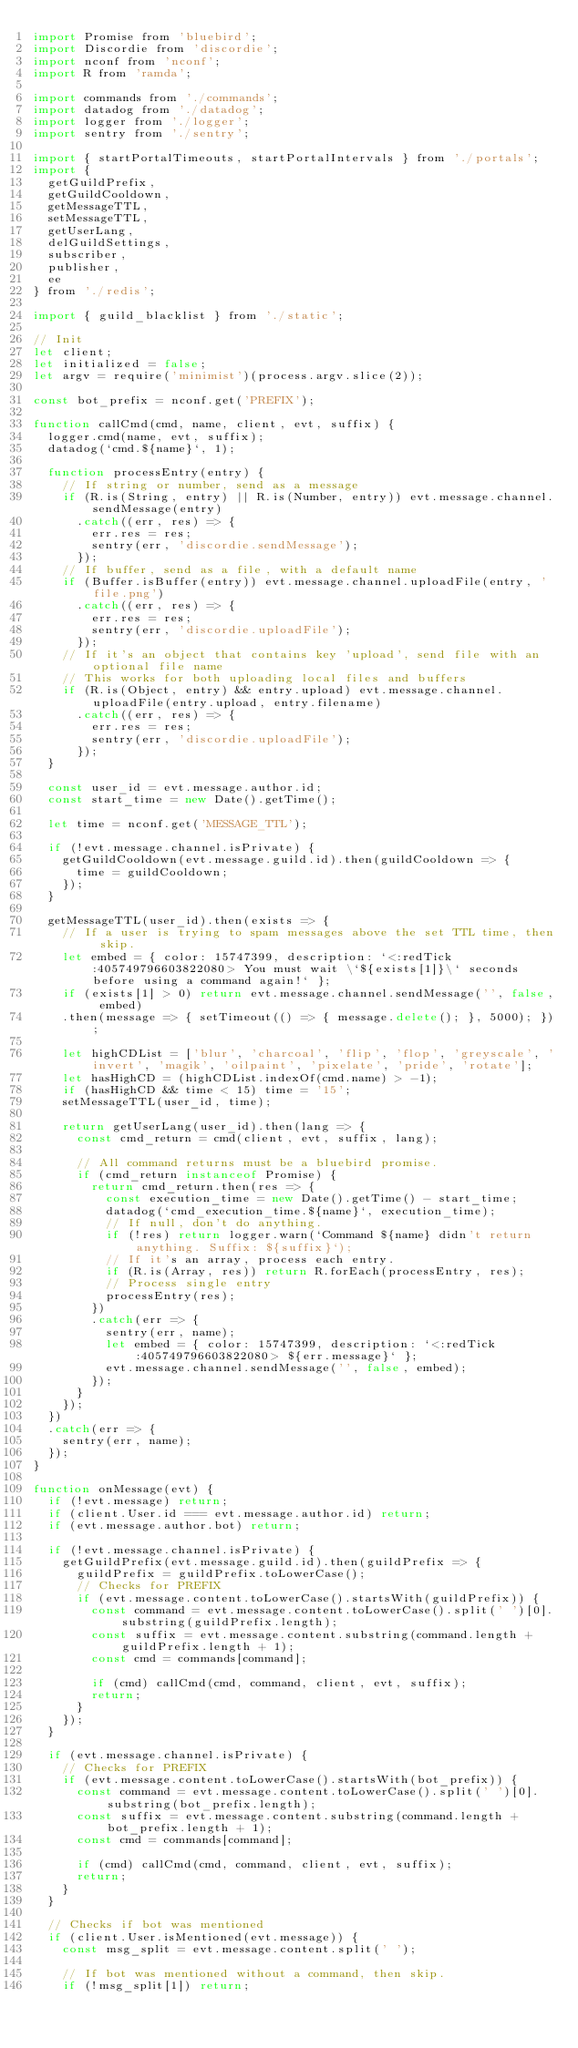Convert code to text. <code><loc_0><loc_0><loc_500><loc_500><_JavaScript_>import Promise from 'bluebird';
import Discordie from 'discordie';
import nconf from 'nconf';
import R from 'ramda';

import commands from './commands';
import datadog from './datadog';
import logger from './logger';
import sentry from './sentry';

import { startPortalTimeouts, startPortalIntervals } from './portals';
import {
  getGuildPrefix,
  getGuildCooldown,
  getMessageTTL,
  setMessageTTL,
  getUserLang,
  delGuildSettings,
  subscriber,
  publisher,
  ee
} from './redis';

import { guild_blacklist } from './static';

// Init
let client;
let initialized = false;
let argv = require('minimist')(process.argv.slice(2));

const bot_prefix = nconf.get('PREFIX');

function callCmd(cmd, name, client, evt, suffix) {
  logger.cmd(name, evt, suffix);
  datadog(`cmd.${name}`, 1);

  function processEntry(entry) {
    // If string or number, send as a message
    if (R.is(String, entry) || R.is(Number, entry)) evt.message.channel.sendMessage(entry)
      .catch((err, res) => {
        err.res = res;
        sentry(err, 'discordie.sendMessage');
      });
    // If buffer, send as a file, with a default name
    if (Buffer.isBuffer(entry)) evt.message.channel.uploadFile(entry, 'file.png')
      .catch((err, res) => {
        err.res = res;
        sentry(err, 'discordie.uploadFile');
      });
    // If it's an object that contains key 'upload', send file with an optional file name
    // This works for both uploading local files and buffers
    if (R.is(Object, entry) && entry.upload) evt.message.channel.uploadFile(entry.upload, entry.filename)
      .catch((err, res) => {
        err.res = res;
        sentry(err, 'discordie.uploadFile');
      });
  }

  const user_id = evt.message.author.id;
  const start_time = new Date().getTime();

  let time = nconf.get('MESSAGE_TTL');

  if (!evt.message.channel.isPrivate) {
    getGuildCooldown(evt.message.guild.id).then(guildCooldown => {
      time = guildCooldown;
    });
  }

  getMessageTTL(user_id).then(exists => {
    // If a user is trying to spam messages above the set TTL time, then skip.
    let embed = { color: 15747399, description: `<:redTick:405749796603822080> You must wait \`${exists[1]}\` seconds before using a command again!` };
    if (exists[1] > 0) return evt.message.channel.sendMessage('', false, embed)
    .then(message => { setTimeout(() => { message.delete(); }, 5000); });

    let highCDList = ['blur', 'charcoal', 'flip', 'flop', 'greyscale', 'invert', 'magik', 'oilpaint', 'pixelate', 'pride', 'rotate'];
    let hasHighCD = (highCDList.indexOf(cmd.name) > -1);
    if (hasHighCD && time < 15) time = '15';
    setMessageTTL(user_id, time);

    return getUserLang(user_id).then(lang => {
      const cmd_return = cmd(client, evt, suffix, lang);

      // All command returns must be a bluebird promise.
      if (cmd_return instanceof Promise) {
        return cmd_return.then(res => {
          const execution_time = new Date().getTime() - start_time;
          datadog(`cmd_execution_time.${name}`, execution_time);
          // If null, don't do anything.
          if (!res) return logger.warn(`Command ${name} didn't return anything. Suffix: ${suffix}`);
          // If it's an array, process each entry.
          if (R.is(Array, res)) return R.forEach(processEntry, res);
          // Process single entry
          processEntry(res);
        })
        .catch(err => {
          sentry(err, name);
          let embed = { color: 15747399, description: `<:redTick:405749796603822080> ${err.message}` };
          evt.message.channel.sendMessage('', false, embed);
        });
      }
    });
  })
  .catch(err => {
    sentry(err, name);
  });
}

function onMessage(evt) {
  if (!evt.message) return;
  if (client.User.id === evt.message.author.id) return;
  if (evt.message.author.bot) return;

  if (!evt.message.channel.isPrivate) {
    getGuildPrefix(evt.message.guild.id).then(guildPrefix => {
      guildPrefix = guildPrefix.toLowerCase();
      // Checks for PREFIX
      if (evt.message.content.toLowerCase().startsWith(guildPrefix)) {
        const command = evt.message.content.toLowerCase().split(' ')[0].substring(guildPrefix.length);
        const suffix = evt.message.content.substring(command.length + guildPrefix.length + 1);
        const cmd = commands[command];

        if (cmd) callCmd(cmd, command, client, evt, suffix);
        return;
      }
    });
  }

  if (evt.message.channel.isPrivate) {
    // Checks for PREFIX
    if (evt.message.content.toLowerCase().startsWith(bot_prefix)) {
      const command = evt.message.content.toLowerCase().split(' ')[0].substring(bot_prefix.length);
      const suffix = evt.message.content.substring(command.length + bot_prefix.length + 1);
      const cmd = commands[command];

      if (cmd) callCmd(cmd, command, client, evt, suffix);
      return;
    }
  }

  // Checks if bot was mentioned
  if (client.User.isMentioned(evt.message)) {
    const msg_split = evt.message.content.split(' ');

    // If bot was mentioned without a command, then skip.
    if (!msg_split[1]) return;
</code> 